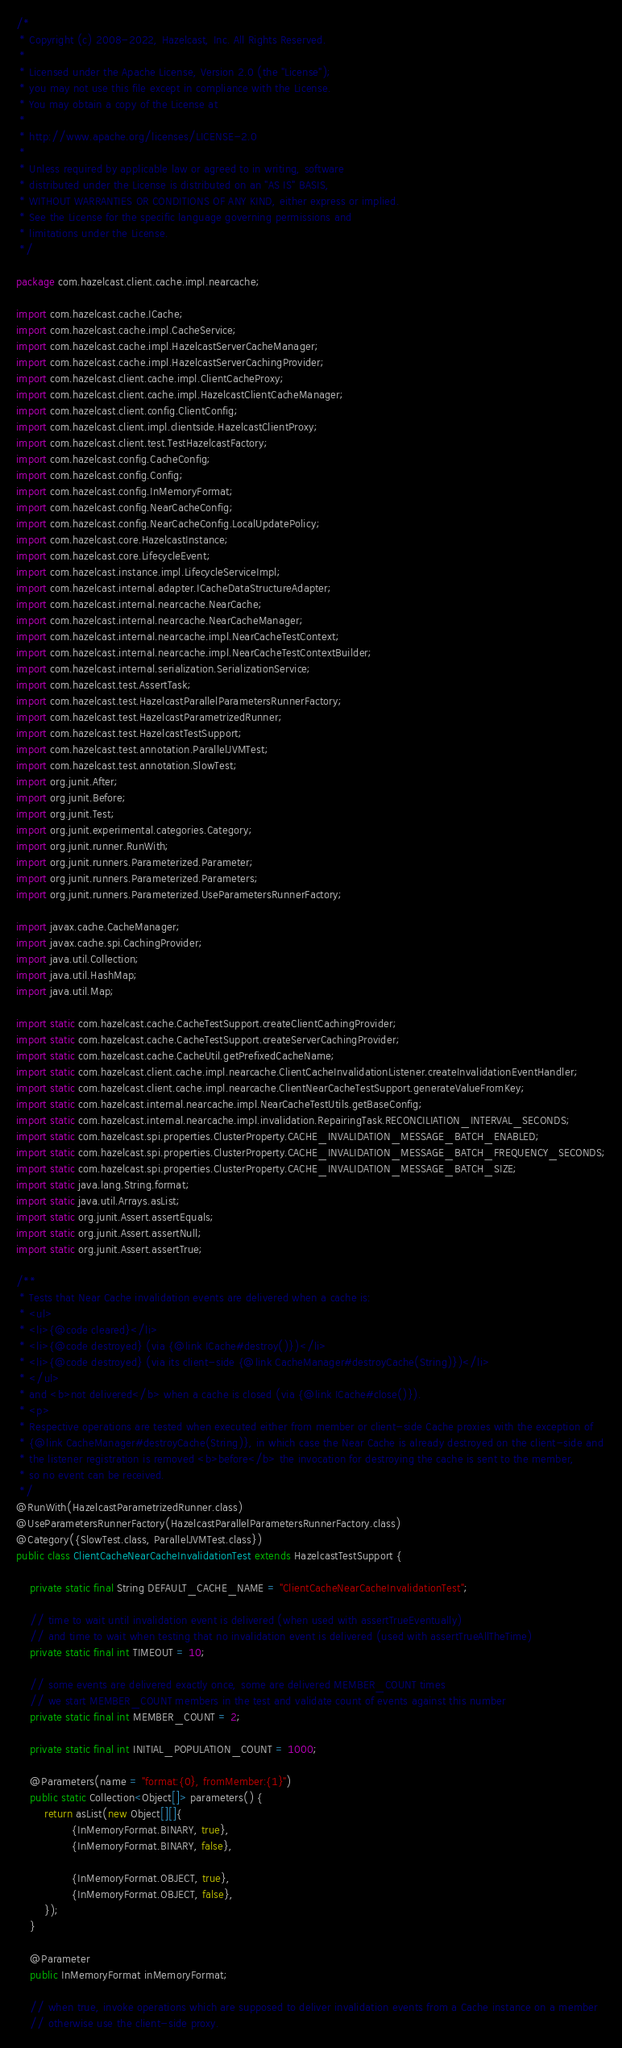Convert code to text. <code><loc_0><loc_0><loc_500><loc_500><_Java_>/*
 * Copyright (c) 2008-2022, Hazelcast, Inc. All Rights Reserved.
 *
 * Licensed under the Apache License, Version 2.0 (the "License");
 * you may not use this file except in compliance with the License.
 * You may obtain a copy of the License at
 *
 * http://www.apache.org/licenses/LICENSE-2.0
 *
 * Unless required by applicable law or agreed to in writing, software
 * distributed under the License is distributed on an "AS IS" BASIS,
 * WITHOUT WARRANTIES OR CONDITIONS OF ANY KIND, either express or implied.
 * See the License for the specific language governing permissions and
 * limitations under the License.
 */

package com.hazelcast.client.cache.impl.nearcache;

import com.hazelcast.cache.ICache;
import com.hazelcast.cache.impl.CacheService;
import com.hazelcast.cache.impl.HazelcastServerCacheManager;
import com.hazelcast.cache.impl.HazelcastServerCachingProvider;
import com.hazelcast.client.cache.impl.ClientCacheProxy;
import com.hazelcast.client.cache.impl.HazelcastClientCacheManager;
import com.hazelcast.client.config.ClientConfig;
import com.hazelcast.client.impl.clientside.HazelcastClientProxy;
import com.hazelcast.client.test.TestHazelcastFactory;
import com.hazelcast.config.CacheConfig;
import com.hazelcast.config.Config;
import com.hazelcast.config.InMemoryFormat;
import com.hazelcast.config.NearCacheConfig;
import com.hazelcast.config.NearCacheConfig.LocalUpdatePolicy;
import com.hazelcast.core.HazelcastInstance;
import com.hazelcast.core.LifecycleEvent;
import com.hazelcast.instance.impl.LifecycleServiceImpl;
import com.hazelcast.internal.adapter.ICacheDataStructureAdapter;
import com.hazelcast.internal.nearcache.NearCache;
import com.hazelcast.internal.nearcache.NearCacheManager;
import com.hazelcast.internal.nearcache.impl.NearCacheTestContext;
import com.hazelcast.internal.nearcache.impl.NearCacheTestContextBuilder;
import com.hazelcast.internal.serialization.SerializationService;
import com.hazelcast.test.AssertTask;
import com.hazelcast.test.HazelcastParallelParametersRunnerFactory;
import com.hazelcast.test.HazelcastParametrizedRunner;
import com.hazelcast.test.HazelcastTestSupport;
import com.hazelcast.test.annotation.ParallelJVMTest;
import com.hazelcast.test.annotation.SlowTest;
import org.junit.After;
import org.junit.Before;
import org.junit.Test;
import org.junit.experimental.categories.Category;
import org.junit.runner.RunWith;
import org.junit.runners.Parameterized.Parameter;
import org.junit.runners.Parameterized.Parameters;
import org.junit.runners.Parameterized.UseParametersRunnerFactory;

import javax.cache.CacheManager;
import javax.cache.spi.CachingProvider;
import java.util.Collection;
import java.util.HashMap;
import java.util.Map;

import static com.hazelcast.cache.CacheTestSupport.createClientCachingProvider;
import static com.hazelcast.cache.CacheTestSupport.createServerCachingProvider;
import static com.hazelcast.cache.CacheUtil.getPrefixedCacheName;
import static com.hazelcast.client.cache.impl.nearcache.ClientCacheInvalidationListener.createInvalidationEventHandler;
import static com.hazelcast.client.cache.impl.nearcache.ClientNearCacheTestSupport.generateValueFromKey;
import static com.hazelcast.internal.nearcache.impl.NearCacheTestUtils.getBaseConfig;
import static com.hazelcast.internal.nearcache.impl.invalidation.RepairingTask.RECONCILIATION_INTERVAL_SECONDS;
import static com.hazelcast.spi.properties.ClusterProperty.CACHE_INVALIDATION_MESSAGE_BATCH_ENABLED;
import static com.hazelcast.spi.properties.ClusterProperty.CACHE_INVALIDATION_MESSAGE_BATCH_FREQUENCY_SECONDS;
import static com.hazelcast.spi.properties.ClusterProperty.CACHE_INVALIDATION_MESSAGE_BATCH_SIZE;
import static java.lang.String.format;
import static java.util.Arrays.asList;
import static org.junit.Assert.assertEquals;
import static org.junit.Assert.assertNull;
import static org.junit.Assert.assertTrue;

/**
 * Tests that Near Cache invalidation events are delivered when a cache is:
 * <ul>
 * <li>{@code cleared}</li>
 * <li>{@code destroyed} (via {@link ICache#destroy()})</li>
 * <li>{@code destroyed} (via its client-side {@link CacheManager#destroyCache(String)})</li>
 * </ul>
 * and <b>not delivered</b> when a cache is closed (via {@link ICache#close()}).
 * <p>
 * Respective operations are tested when executed either from member or client-side Cache proxies with the exception of
 * {@link CacheManager#destroyCache(String)}, in which case the Near Cache is already destroyed on the client-side and
 * the listener registration is removed <b>before</b> the invocation for destroying the cache is sent to the member,
 * so no event can be received.
 */
@RunWith(HazelcastParametrizedRunner.class)
@UseParametersRunnerFactory(HazelcastParallelParametersRunnerFactory.class)
@Category({SlowTest.class, ParallelJVMTest.class})
public class ClientCacheNearCacheInvalidationTest extends HazelcastTestSupport {

    private static final String DEFAULT_CACHE_NAME = "ClientCacheNearCacheInvalidationTest";

    // time to wait until invalidation event is delivered (when used with assertTrueEventually)
    // and time to wait when testing that no invalidation event is delivered (used with assertTrueAllTheTime)
    private static final int TIMEOUT = 10;

    // some events are delivered exactly once, some are delivered MEMBER_COUNT times
    // we start MEMBER_COUNT members in the test and validate count of events against this number
    private static final int MEMBER_COUNT = 2;

    private static final int INITIAL_POPULATION_COUNT = 1000;

    @Parameters(name = "format:{0}, fromMember:{1}")
    public static Collection<Object[]> parameters() {
        return asList(new Object[][]{
                {InMemoryFormat.BINARY, true},
                {InMemoryFormat.BINARY, false},

                {InMemoryFormat.OBJECT, true},
                {InMemoryFormat.OBJECT, false},
        });
    }

    @Parameter
    public InMemoryFormat inMemoryFormat;

    // when true, invoke operations which are supposed to deliver invalidation events from a Cache instance on a member
    // otherwise use the client-side proxy.</code> 